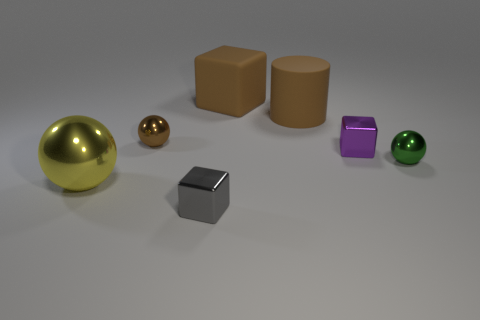There is a small gray thing; is it the same shape as the small object left of the gray thing?
Your response must be concise. No. What number of other objects are there of the same shape as the brown metal thing?
Give a very brief answer. 2. What number of objects are either brown rubber cylinders or green things?
Provide a short and direct response. 2. Is the color of the big metal ball the same as the large block?
Offer a very short reply. No. Is there any other thing that is the same size as the brown rubber cylinder?
Your answer should be very brief. Yes. What is the shape of the shiny thing that is to the right of the purple thing that is to the right of the large rubber cylinder?
Offer a terse response. Sphere. Are there fewer large rubber objects than big yellow spheres?
Your response must be concise. No. There is a brown thing that is both behind the tiny brown object and on the left side of the big rubber cylinder; how big is it?
Your response must be concise. Large. Do the yellow thing and the brown metallic ball have the same size?
Provide a short and direct response. No. There is a big thing on the left side of the gray shiny thing; does it have the same color as the large rubber cylinder?
Offer a terse response. No. 